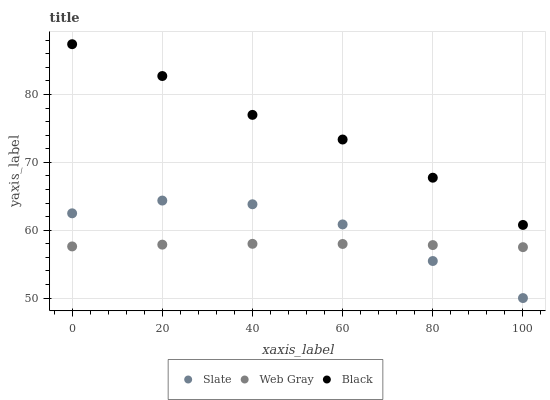Does Web Gray have the minimum area under the curve?
Answer yes or no. Yes. Does Black have the maximum area under the curve?
Answer yes or no. Yes. Does Black have the minimum area under the curve?
Answer yes or no. No. Does Web Gray have the maximum area under the curve?
Answer yes or no. No. Is Web Gray the smoothest?
Answer yes or no. Yes. Is Slate the roughest?
Answer yes or no. Yes. Is Black the smoothest?
Answer yes or no. No. Is Black the roughest?
Answer yes or no. No. Does Slate have the lowest value?
Answer yes or no. Yes. Does Web Gray have the lowest value?
Answer yes or no. No. Does Black have the highest value?
Answer yes or no. Yes. Does Web Gray have the highest value?
Answer yes or no. No. Is Web Gray less than Black?
Answer yes or no. Yes. Is Black greater than Slate?
Answer yes or no. Yes. Does Web Gray intersect Slate?
Answer yes or no. Yes. Is Web Gray less than Slate?
Answer yes or no. No. Is Web Gray greater than Slate?
Answer yes or no. No. Does Web Gray intersect Black?
Answer yes or no. No. 